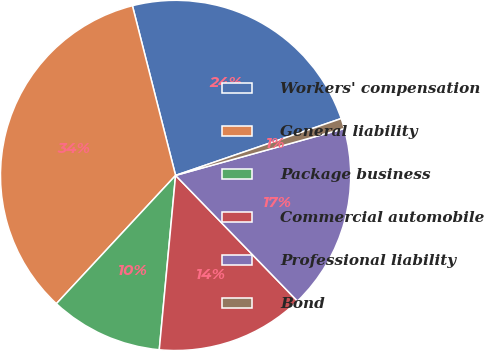<chart> <loc_0><loc_0><loc_500><loc_500><pie_chart><fcel>Workers' compensation<fcel>General liability<fcel>Package business<fcel>Commercial automobile<fcel>Professional liability<fcel>Bond<nl><fcel>23.7%<fcel>34.12%<fcel>10.43%<fcel>13.74%<fcel>17.06%<fcel>0.95%<nl></chart> 